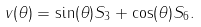Convert formula to latex. <formula><loc_0><loc_0><loc_500><loc_500>v ( \theta ) = \sin ( \theta ) S _ { 3 } + \cos ( \theta ) S _ { 6 } .</formula> 